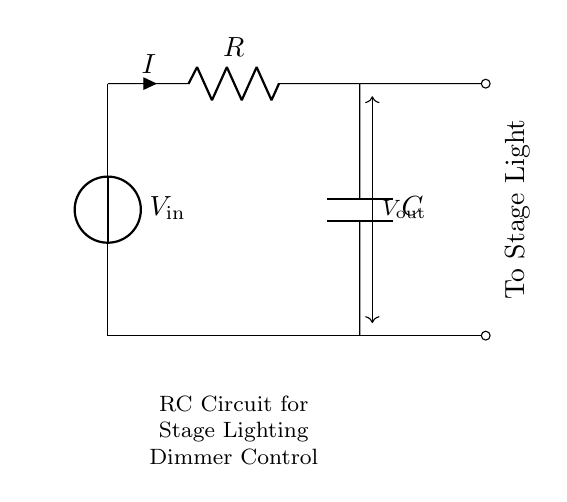What is the function of the capacitor in this circuit? The capacitor stores electrical energy and controls the timing of the circuit by charging and discharging. In this dimmer control application, it helps to adjust the brightness of the stage lights by affecting the current flow.
Answer: Stores energy What are the components shown in the circuit? The circuit contains a voltage source, a resistor, and a capacitor. These are the basic components of an RC circuit used for dimming lights.
Answer: Voltage source, resistor, capacitor What is the current direction in this circuit? The current typically flows from the positive terminal of the voltage source, through the resistor, to the capacitor, and then back to the negative terminal of the voltage source.
Answer: From positive to negative What does R represent in this circuit? R represents the resistance in ohms (Ω) that limits the current flowing through the circuit. It plays a crucial role in determining how fast the capacitor charges and discharges.
Answer: Resistance How does increasing the resistance affect the circuit behavior? Increasing the resistance slows down the rate at which the capacitor charges and discharges, resulting in a slower change in the output voltage and thereby dimming the lights more gradually.
Answer: Slows down dimming What is the relationship between the resistor and capacitor in this circuit? The resistor and capacitor form a time constant (τ) in the circuit, defined as τ = R * C. This time constant determines how quickly the circuit responds to voltage changes and affects the dimming level.
Answer: Defines time constant 